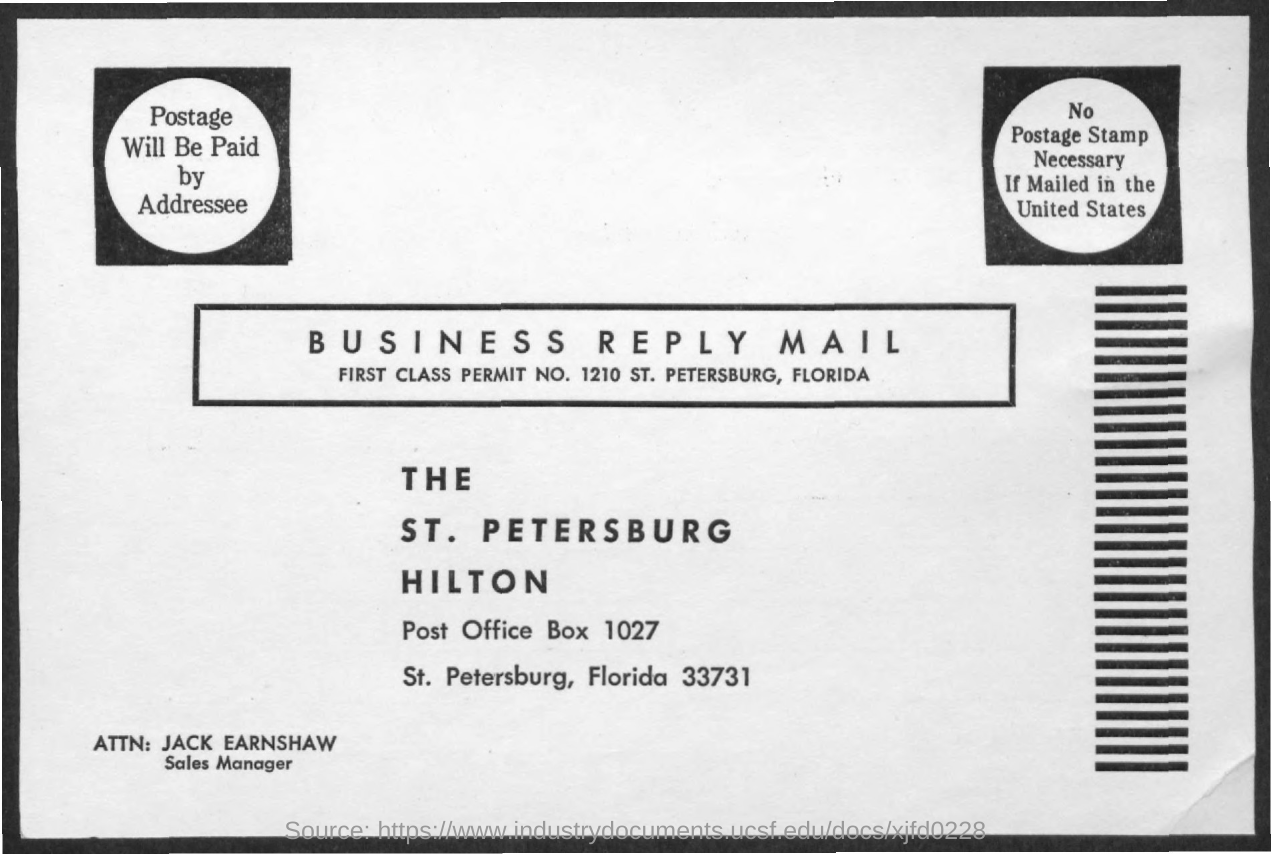Mention a couple of crucial points in this snapshot. The postal box number given in the address is "Post Office Box 1027. The first class permit number mentioned in the business reply mail is 1210. Jack Earnsaw is designated as the Sales Manager. 